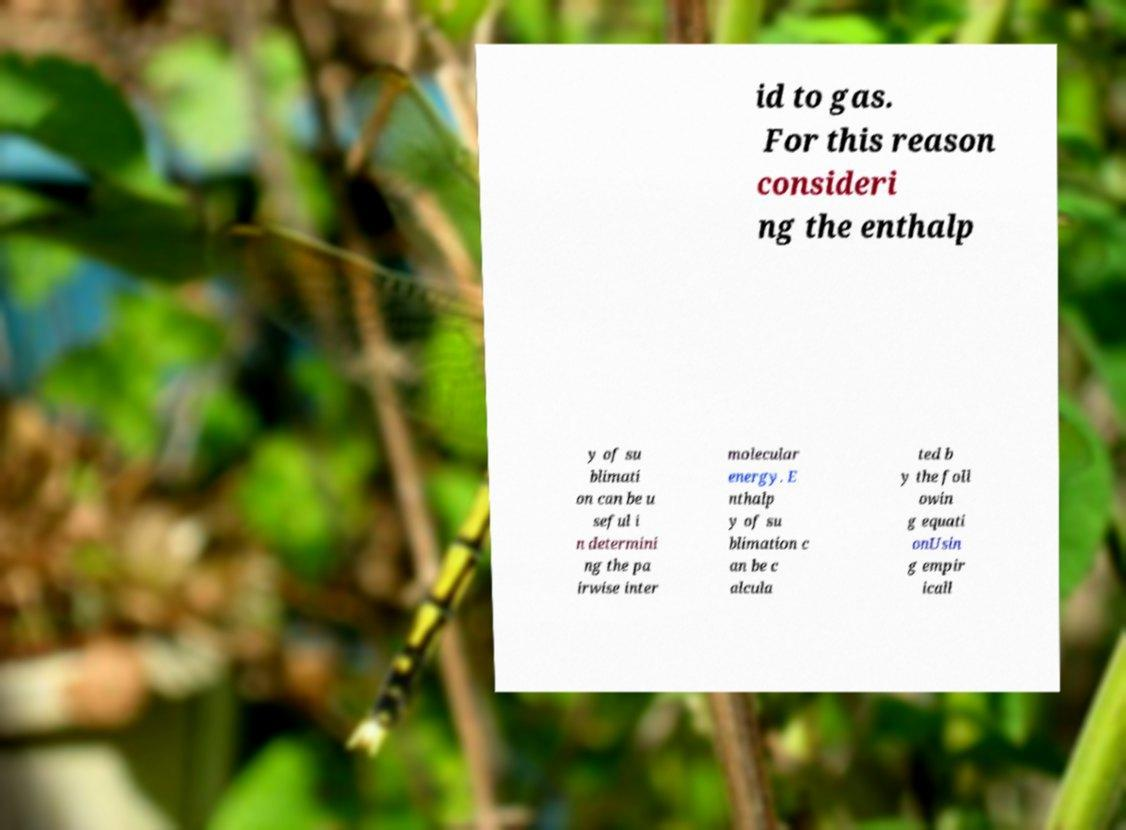Could you assist in decoding the text presented in this image and type it out clearly? id to gas. For this reason consideri ng the enthalp y of su blimati on can be u seful i n determini ng the pa irwise inter molecular energy. E nthalp y of su blimation c an be c alcula ted b y the foll owin g equati onUsin g empir icall 